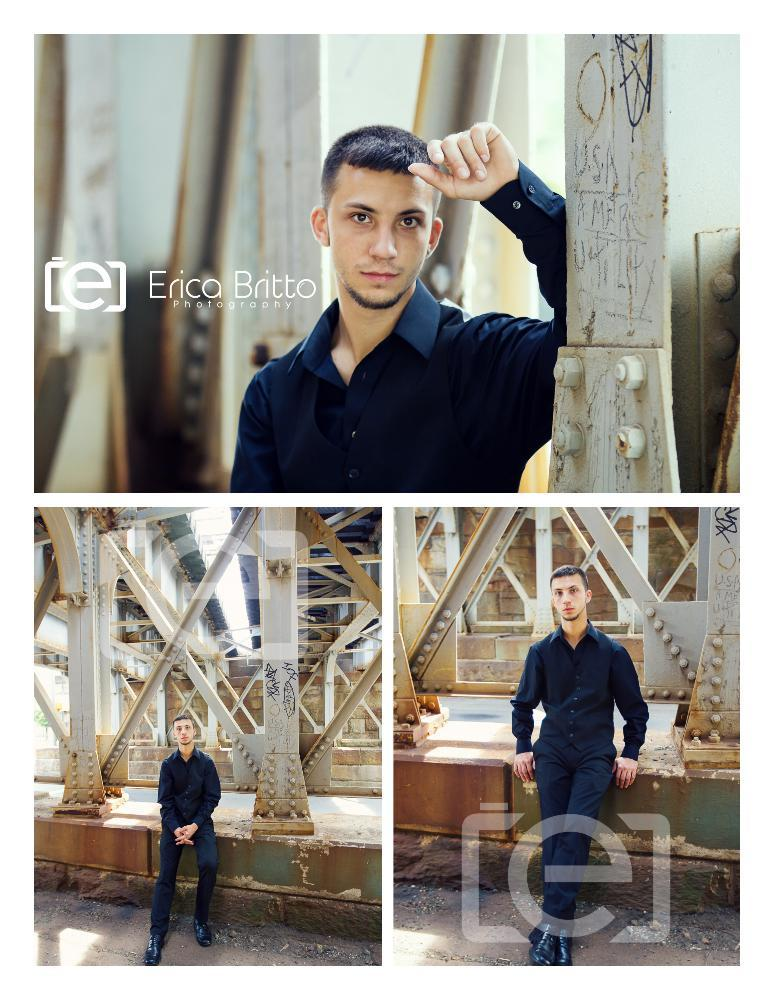Who is present in the image? There is a person in the image. What is the person wearing? The person is wearing a black dress. What other objects can be seen in the image? There are poles in the image. Is there any artwork or additional images in the scene? Yes, there is a collage image in the scene. What type of cakes are being served at the event in the image? There is no event or cakes present in the image; it features a person wearing a black dress, poles, and a collage image. Does the existence of the person in the image prove the existence of extraterrestrial life? The presence of a person in the image does not prove the existence of extraterrestrial life, as the image only depicts a person wearing a black dress, poles, and a collage image. 